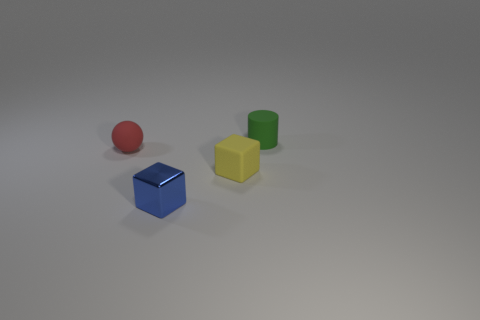Is there any other thing that has the same material as the blue cube?
Keep it short and to the point. No. What number of tiny green things are the same shape as the red thing?
Your answer should be compact. 0. The sphere that is the same material as the cylinder is what size?
Provide a succinct answer. Small. What material is the tiny thing that is behind the small rubber cube and right of the red rubber thing?
Make the answer very short. Rubber. How many matte blocks have the same size as the red rubber thing?
Provide a succinct answer. 1. What material is the blue object that is the same shape as the tiny yellow rubber object?
Your response must be concise. Metal. How many things are either objects in front of the green object or small rubber objects that are to the left of the blue shiny thing?
Your answer should be very brief. 3. There is a tiny yellow matte object; does it have the same shape as the rubber object that is on the left side of the yellow matte thing?
Give a very brief answer. No. The matte object that is in front of the thing on the left side of the small block to the left of the yellow cube is what shape?
Keep it short and to the point. Cube. How many other objects are there of the same material as the blue thing?
Keep it short and to the point. 0. 